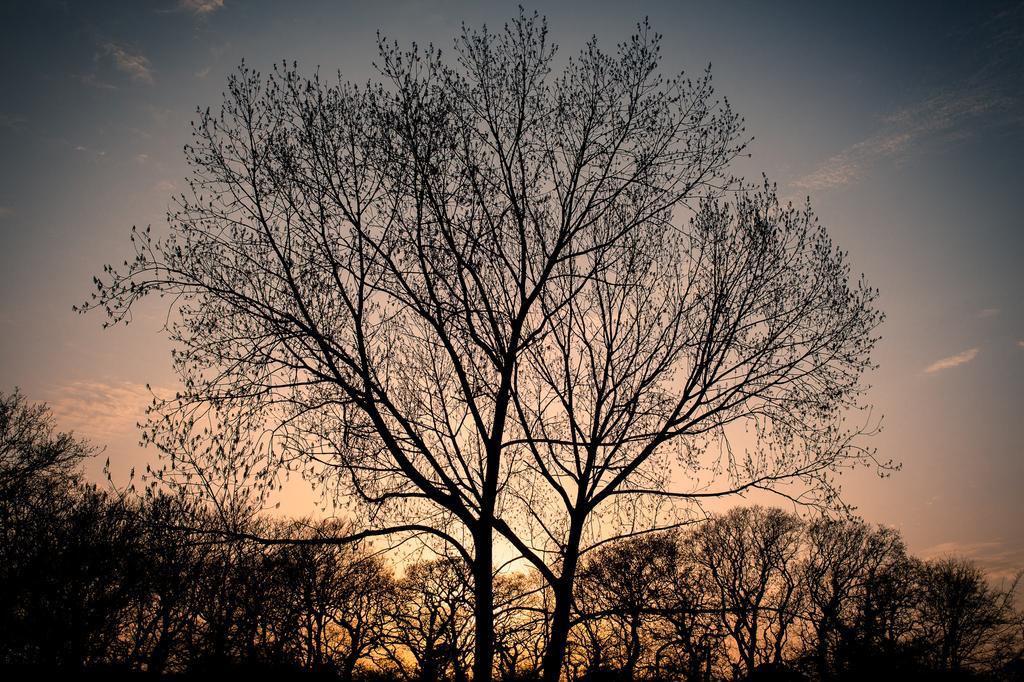In one or two sentences, can you explain what this image depicts? In the image we can see trees and the sky. 